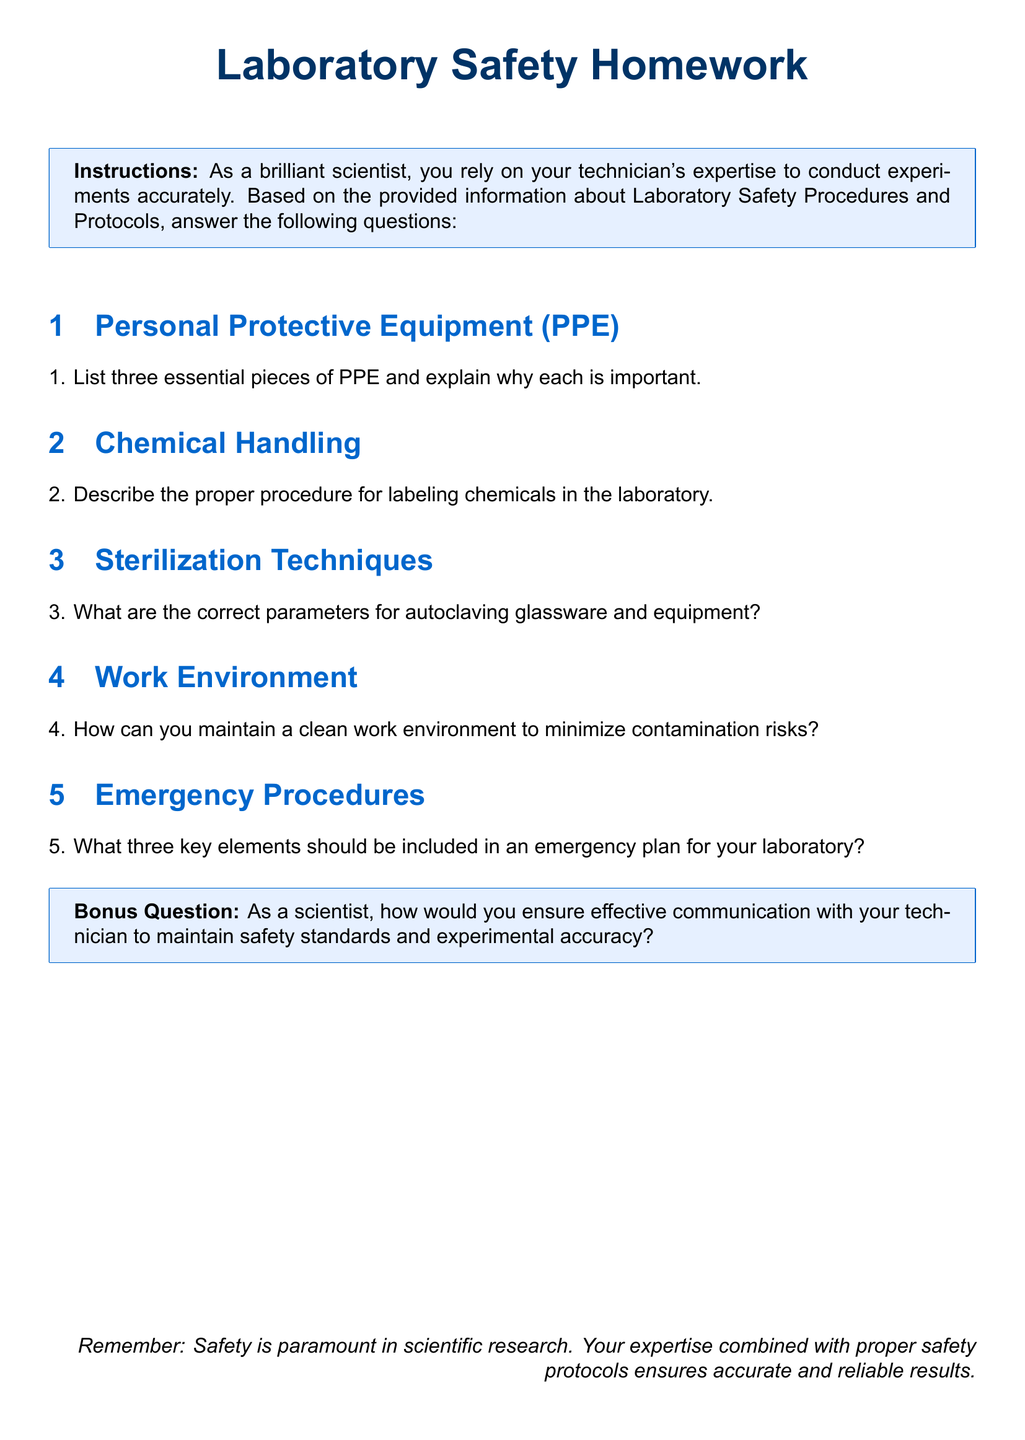What are three essential pieces of PPE? The document requests a list of three essential pieces of PPE in a section dedicated to Personal Protective Equipment.
Answer: Three essential pieces of PPE What is the purpose of labeling chemicals? The document includes a section describing proper procedures for chemical handling, which typically highlights the importance of labeling.
Answer: To avoid confusion What are the correct parameters for autoclaving? The document specifies that there is a section on sterilization techniques that addresses autoclaving parameters.
Answer: Correct parameters for autoclaving What should be maintained to minimize contamination? In the section about the work environment, it mentions maintaining a clean environment to reduce contamination risks.
Answer: A clean work environment What three key elements must be included in an emergency plan? The document outlines emergency procedures that highlight three key elements necessary for an emergency plan.
Answer: Three key elements What is the bonus question about? The document has a bonus question related to the importance of communication between a scientist and technician to ensure safety and accuracy.
Answer: Effective communication 